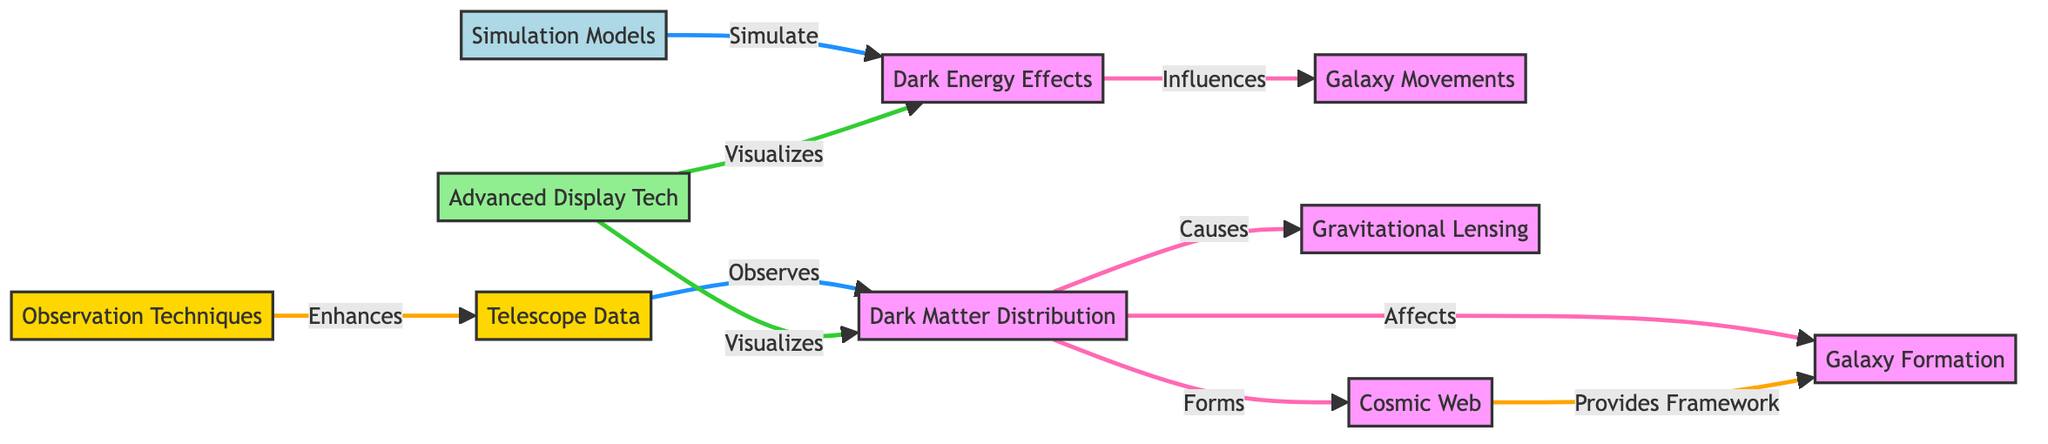What is listed as a cause of gravitational lensing? The diagram shows that dark matter is identified as a cause of gravitational lensing, as indicated by the arrow from "Dark Matter Distribution" to "Gravitational Lensing".
Answer: Dark Matter Distribution How many observation techniques are represented? In the diagram, there are two observation techniques noted: "Telescope Data" and "Observation Techniques". This indicates there are two nodes related to observing.
Answer: 2 Which node influences galaxy movements? The diagram indicates that dark energy influences galaxy movements, as there is a direct arrow from "Dark Energy Effects" to "Galaxy Movements".
Answer: Dark Energy Effects What does advanced display technology visualize? The diagram shows that advanced display technology visualizes both dark matter and dark energy, as there are arrows pointing from "Advanced Display Tech" to both of these nodes.
Answer: Dark Matter and Dark Energy Which element provides a framework for galaxy formation? The "Cosmic Web" is indicated as providing a framework for galaxy formation, as the flowchart has an arrow coming from "Cosmic Web" to "Galaxy Formation".
Answer: Cosmic Web What are the two types of data mentioned for observations? The visualization includes two types of data for observations: "Telescope Data" and "Observation Techniques", which are both labeled under the observation group.
Answer: Telescope Data and Observation Techniques Explain how dark matter affects galaxy formation? The diagram shows a direct relationship where dark matter affects galaxy formation represented by the arrow leading from "Dark Matter Distribution" to "Galaxy Formation". Thus, dark matter plays a vital role in the formation of galaxies.
Answer: Affects What is the relationship between simulation models and dark energy effects? According to the diagram, simulation models are used to simulate dark energy effects as indicated by the direct connection from "Simulation Models" to "Dark Energy Effects".
Answer: Simulate 